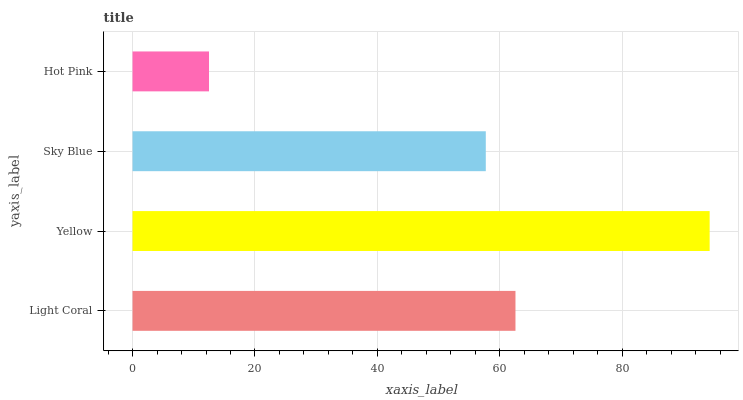Is Hot Pink the minimum?
Answer yes or no. Yes. Is Yellow the maximum?
Answer yes or no. Yes. Is Sky Blue the minimum?
Answer yes or no. No. Is Sky Blue the maximum?
Answer yes or no. No. Is Yellow greater than Sky Blue?
Answer yes or no. Yes. Is Sky Blue less than Yellow?
Answer yes or no. Yes. Is Sky Blue greater than Yellow?
Answer yes or no. No. Is Yellow less than Sky Blue?
Answer yes or no. No. Is Light Coral the high median?
Answer yes or no. Yes. Is Sky Blue the low median?
Answer yes or no. Yes. Is Yellow the high median?
Answer yes or no. No. Is Yellow the low median?
Answer yes or no. No. 